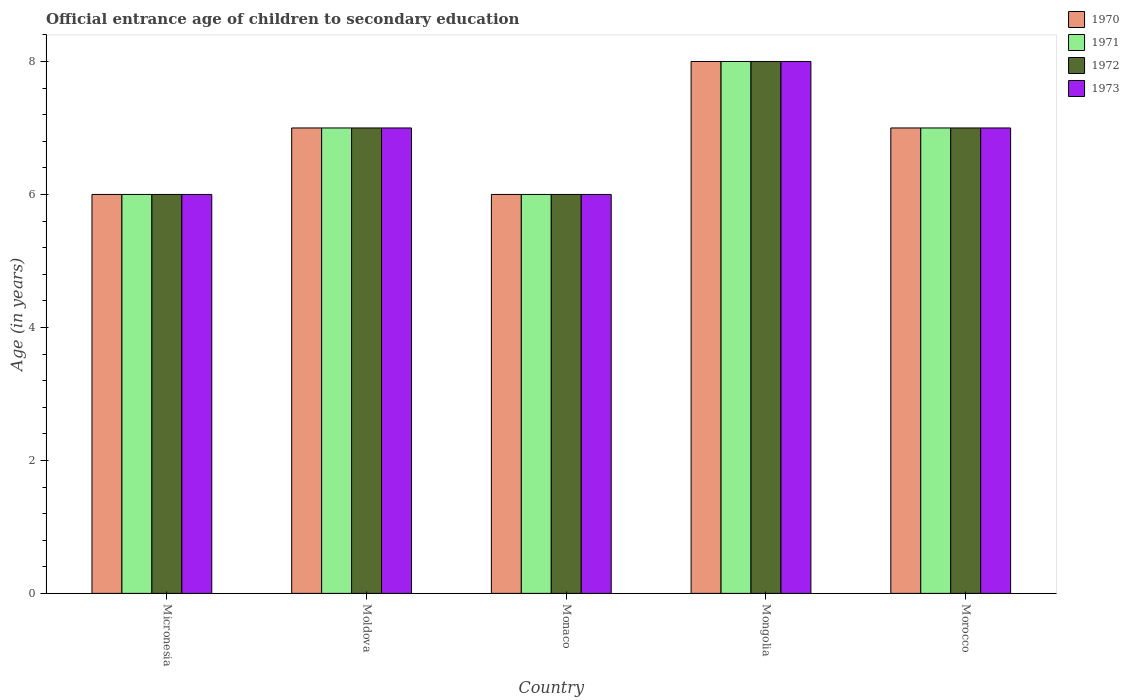How many groups of bars are there?
Offer a very short reply. 5. Are the number of bars per tick equal to the number of legend labels?
Provide a succinct answer. Yes. Are the number of bars on each tick of the X-axis equal?
Offer a very short reply. Yes. How many bars are there on the 2nd tick from the left?
Your response must be concise. 4. How many bars are there on the 1st tick from the right?
Ensure brevity in your answer.  4. What is the label of the 3rd group of bars from the left?
Provide a short and direct response. Monaco. What is the secondary school starting age of children in 1972 in Moldova?
Ensure brevity in your answer.  7. In which country was the secondary school starting age of children in 1970 maximum?
Your answer should be very brief. Mongolia. In which country was the secondary school starting age of children in 1973 minimum?
Keep it short and to the point. Micronesia. What is the total secondary school starting age of children in 1973 in the graph?
Provide a succinct answer. 34. What is the difference between the secondary school starting age of children in 1971 in Micronesia and that in Morocco?
Provide a succinct answer. -1. What is the average secondary school starting age of children in 1972 per country?
Your answer should be compact. 6.8. What is the difference between the secondary school starting age of children of/in 1970 and secondary school starting age of children of/in 1972 in Morocco?
Provide a short and direct response. 0. In how many countries, is the secondary school starting age of children in 1972 greater than 3.6 years?
Give a very brief answer. 5. What is the ratio of the secondary school starting age of children in 1971 in Monaco to that in Mongolia?
Make the answer very short. 0.75. Is the secondary school starting age of children in 1971 in Moldova less than that in Morocco?
Your answer should be very brief. No. Is the sum of the secondary school starting age of children in 1973 in Monaco and Morocco greater than the maximum secondary school starting age of children in 1972 across all countries?
Your answer should be compact. Yes. Is it the case that in every country, the sum of the secondary school starting age of children in 1973 and secondary school starting age of children in 1972 is greater than the sum of secondary school starting age of children in 1970 and secondary school starting age of children in 1971?
Provide a short and direct response. No. What does the 3rd bar from the left in Micronesia represents?
Your answer should be very brief. 1972. What does the 4th bar from the right in Monaco represents?
Your response must be concise. 1970. Is it the case that in every country, the sum of the secondary school starting age of children in 1970 and secondary school starting age of children in 1972 is greater than the secondary school starting age of children in 1971?
Offer a very short reply. Yes. How many bars are there?
Provide a succinct answer. 20. Are all the bars in the graph horizontal?
Provide a succinct answer. No. What is the difference between two consecutive major ticks on the Y-axis?
Offer a terse response. 2. How are the legend labels stacked?
Offer a very short reply. Vertical. What is the title of the graph?
Offer a very short reply. Official entrance age of children to secondary education. Does "2001" appear as one of the legend labels in the graph?
Offer a very short reply. No. What is the label or title of the Y-axis?
Offer a very short reply. Age (in years). What is the Age (in years) in 1970 in Micronesia?
Offer a very short reply. 6. What is the Age (in years) of 1970 in Moldova?
Offer a very short reply. 7. What is the Age (in years) in 1973 in Moldova?
Offer a terse response. 7. What is the Age (in years) of 1970 in Monaco?
Your answer should be very brief. 6. What is the Age (in years) in 1972 in Monaco?
Your answer should be compact. 6. What is the Age (in years) of 1973 in Monaco?
Offer a very short reply. 6. What is the Age (in years) in 1971 in Mongolia?
Offer a terse response. 8. What is the Age (in years) of 1972 in Mongolia?
Your response must be concise. 8. What is the Age (in years) in 1970 in Morocco?
Your response must be concise. 7. What is the Age (in years) in 1971 in Morocco?
Ensure brevity in your answer.  7. Across all countries, what is the maximum Age (in years) of 1970?
Offer a very short reply. 8. Across all countries, what is the maximum Age (in years) of 1972?
Provide a short and direct response. 8. Across all countries, what is the minimum Age (in years) of 1971?
Offer a very short reply. 6. Across all countries, what is the minimum Age (in years) in 1972?
Ensure brevity in your answer.  6. What is the total Age (in years) in 1970 in the graph?
Your answer should be compact. 34. What is the total Age (in years) of 1971 in the graph?
Offer a terse response. 34. What is the total Age (in years) of 1972 in the graph?
Your response must be concise. 34. What is the difference between the Age (in years) of 1972 in Micronesia and that in Moldova?
Ensure brevity in your answer.  -1. What is the difference between the Age (in years) in 1973 in Micronesia and that in Moldova?
Provide a succinct answer. -1. What is the difference between the Age (in years) of 1971 in Micronesia and that in Monaco?
Your answer should be very brief. 0. What is the difference between the Age (in years) in 1972 in Micronesia and that in Monaco?
Your answer should be compact. 0. What is the difference between the Age (in years) of 1973 in Micronesia and that in Mongolia?
Your answer should be compact. -2. What is the difference between the Age (in years) of 1971 in Micronesia and that in Morocco?
Your response must be concise. -1. What is the difference between the Age (in years) in 1972 in Micronesia and that in Morocco?
Offer a terse response. -1. What is the difference between the Age (in years) of 1971 in Moldova and that in Monaco?
Provide a short and direct response. 1. What is the difference between the Age (in years) of 1972 in Moldova and that in Monaco?
Your answer should be very brief. 1. What is the difference between the Age (in years) of 1971 in Moldova and that in Mongolia?
Make the answer very short. -1. What is the difference between the Age (in years) of 1970 in Moldova and that in Morocco?
Offer a terse response. 0. What is the difference between the Age (in years) in 1973 in Moldova and that in Morocco?
Provide a succinct answer. 0. What is the difference between the Age (in years) in 1970 in Monaco and that in Morocco?
Your answer should be compact. -1. What is the difference between the Age (in years) in 1972 in Monaco and that in Morocco?
Your response must be concise. -1. What is the difference between the Age (in years) in 1972 in Mongolia and that in Morocco?
Keep it short and to the point. 1. What is the difference between the Age (in years) of 1973 in Mongolia and that in Morocco?
Keep it short and to the point. 1. What is the difference between the Age (in years) of 1970 in Micronesia and the Age (in years) of 1972 in Moldova?
Offer a terse response. -1. What is the difference between the Age (in years) in 1970 in Micronesia and the Age (in years) in 1973 in Moldova?
Provide a short and direct response. -1. What is the difference between the Age (in years) in 1971 in Micronesia and the Age (in years) in 1973 in Moldova?
Provide a succinct answer. -1. What is the difference between the Age (in years) in 1971 in Micronesia and the Age (in years) in 1972 in Monaco?
Give a very brief answer. 0. What is the difference between the Age (in years) of 1972 in Micronesia and the Age (in years) of 1973 in Monaco?
Your answer should be compact. 0. What is the difference between the Age (in years) in 1970 in Micronesia and the Age (in years) in 1972 in Mongolia?
Provide a succinct answer. -2. What is the difference between the Age (in years) in 1970 in Micronesia and the Age (in years) in 1973 in Mongolia?
Offer a terse response. -2. What is the difference between the Age (in years) in 1970 in Micronesia and the Age (in years) in 1971 in Morocco?
Your answer should be compact. -1. What is the difference between the Age (in years) in 1970 in Micronesia and the Age (in years) in 1972 in Morocco?
Provide a short and direct response. -1. What is the difference between the Age (in years) of 1970 in Micronesia and the Age (in years) of 1973 in Morocco?
Keep it short and to the point. -1. What is the difference between the Age (in years) of 1971 in Micronesia and the Age (in years) of 1972 in Morocco?
Keep it short and to the point. -1. What is the difference between the Age (in years) in 1972 in Micronesia and the Age (in years) in 1973 in Morocco?
Offer a very short reply. -1. What is the difference between the Age (in years) of 1970 in Moldova and the Age (in years) of 1973 in Monaco?
Provide a succinct answer. 1. What is the difference between the Age (in years) in 1971 in Moldova and the Age (in years) in 1972 in Monaco?
Give a very brief answer. 1. What is the difference between the Age (in years) of 1971 in Moldova and the Age (in years) of 1973 in Monaco?
Offer a terse response. 1. What is the difference between the Age (in years) in 1970 in Moldova and the Age (in years) in 1972 in Mongolia?
Your answer should be compact. -1. What is the difference between the Age (in years) in 1971 in Moldova and the Age (in years) in 1973 in Mongolia?
Keep it short and to the point. -1. What is the difference between the Age (in years) in 1972 in Moldova and the Age (in years) in 1973 in Mongolia?
Ensure brevity in your answer.  -1. What is the difference between the Age (in years) in 1970 in Moldova and the Age (in years) in 1971 in Morocco?
Provide a succinct answer. 0. What is the difference between the Age (in years) of 1970 in Moldova and the Age (in years) of 1972 in Morocco?
Provide a short and direct response. 0. What is the difference between the Age (in years) in 1971 in Moldova and the Age (in years) in 1973 in Morocco?
Keep it short and to the point. 0. What is the difference between the Age (in years) in 1970 in Monaco and the Age (in years) in 1973 in Mongolia?
Your answer should be compact. -2. What is the difference between the Age (in years) in 1971 in Monaco and the Age (in years) in 1973 in Mongolia?
Give a very brief answer. -2. What is the difference between the Age (in years) of 1971 in Monaco and the Age (in years) of 1973 in Morocco?
Offer a very short reply. -1. What is the difference between the Age (in years) in 1972 in Monaco and the Age (in years) in 1973 in Morocco?
Ensure brevity in your answer.  -1. What is the difference between the Age (in years) in 1971 in Mongolia and the Age (in years) in 1972 in Morocco?
Give a very brief answer. 1. What is the difference between the Age (in years) in 1971 in Mongolia and the Age (in years) in 1973 in Morocco?
Your response must be concise. 1. What is the average Age (in years) of 1970 per country?
Offer a terse response. 6.8. What is the average Age (in years) in 1971 per country?
Provide a short and direct response. 6.8. What is the average Age (in years) of 1972 per country?
Offer a very short reply. 6.8. What is the difference between the Age (in years) in 1971 and Age (in years) in 1973 in Micronesia?
Offer a very short reply. 0. What is the difference between the Age (in years) in 1970 and Age (in years) in 1971 in Moldova?
Make the answer very short. 0. What is the difference between the Age (in years) in 1970 and Age (in years) in 1973 in Moldova?
Provide a short and direct response. 0. What is the difference between the Age (in years) of 1972 and Age (in years) of 1973 in Moldova?
Offer a very short reply. 0. What is the difference between the Age (in years) of 1970 and Age (in years) of 1971 in Monaco?
Your response must be concise. 0. What is the difference between the Age (in years) of 1971 and Age (in years) of 1972 in Monaco?
Your answer should be compact. 0. What is the difference between the Age (in years) in 1970 and Age (in years) in 1972 in Mongolia?
Your answer should be very brief. 0. What is the difference between the Age (in years) in 1970 and Age (in years) in 1973 in Mongolia?
Make the answer very short. 0. What is the difference between the Age (in years) of 1971 and Age (in years) of 1972 in Mongolia?
Make the answer very short. 0. What is the difference between the Age (in years) of 1971 and Age (in years) of 1973 in Mongolia?
Offer a terse response. 0. What is the difference between the Age (in years) of 1970 and Age (in years) of 1972 in Morocco?
Make the answer very short. 0. What is the difference between the Age (in years) of 1970 and Age (in years) of 1973 in Morocco?
Your answer should be very brief. 0. What is the difference between the Age (in years) in 1971 and Age (in years) in 1972 in Morocco?
Your answer should be compact. 0. What is the ratio of the Age (in years) of 1970 in Micronesia to that in Moldova?
Your answer should be compact. 0.86. What is the ratio of the Age (in years) of 1971 in Micronesia to that in Moldova?
Keep it short and to the point. 0.86. What is the ratio of the Age (in years) in 1972 in Micronesia to that in Moldova?
Make the answer very short. 0.86. What is the ratio of the Age (in years) in 1973 in Micronesia to that in Moldova?
Provide a short and direct response. 0.86. What is the ratio of the Age (in years) in 1970 in Micronesia to that in Monaco?
Ensure brevity in your answer.  1. What is the ratio of the Age (in years) in 1972 in Micronesia to that in Monaco?
Your answer should be compact. 1. What is the ratio of the Age (in years) of 1973 in Micronesia to that in Monaco?
Provide a short and direct response. 1. What is the ratio of the Age (in years) of 1970 in Micronesia to that in Mongolia?
Your answer should be very brief. 0.75. What is the ratio of the Age (in years) of 1972 in Micronesia to that in Mongolia?
Keep it short and to the point. 0.75. What is the ratio of the Age (in years) in 1970 in Micronesia to that in Morocco?
Your answer should be very brief. 0.86. What is the ratio of the Age (in years) of 1973 in Micronesia to that in Morocco?
Offer a terse response. 0.86. What is the ratio of the Age (in years) of 1970 in Moldova to that in Monaco?
Keep it short and to the point. 1.17. What is the ratio of the Age (in years) in 1972 in Moldova to that in Monaco?
Give a very brief answer. 1.17. What is the ratio of the Age (in years) in 1970 in Moldova to that in Mongolia?
Provide a succinct answer. 0.88. What is the ratio of the Age (in years) of 1971 in Moldova to that in Mongolia?
Your response must be concise. 0.88. What is the ratio of the Age (in years) of 1972 in Moldova to that in Mongolia?
Keep it short and to the point. 0.88. What is the ratio of the Age (in years) in 1973 in Moldova to that in Mongolia?
Your response must be concise. 0.88. What is the ratio of the Age (in years) in 1970 in Moldova to that in Morocco?
Offer a terse response. 1. What is the ratio of the Age (in years) in 1972 in Moldova to that in Morocco?
Offer a very short reply. 1. What is the ratio of the Age (in years) of 1972 in Monaco to that in Mongolia?
Give a very brief answer. 0.75. What is the ratio of the Age (in years) of 1970 in Monaco to that in Morocco?
Offer a very short reply. 0.86. What is the ratio of the Age (in years) in 1972 in Monaco to that in Morocco?
Your answer should be very brief. 0.86. What is the ratio of the Age (in years) in 1971 in Mongolia to that in Morocco?
Give a very brief answer. 1.14. What is the ratio of the Age (in years) in 1972 in Mongolia to that in Morocco?
Your answer should be compact. 1.14. What is the difference between the highest and the second highest Age (in years) in 1970?
Ensure brevity in your answer.  1. What is the difference between the highest and the second highest Age (in years) in 1971?
Keep it short and to the point. 1. What is the difference between the highest and the second highest Age (in years) in 1973?
Ensure brevity in your answer.  1. 